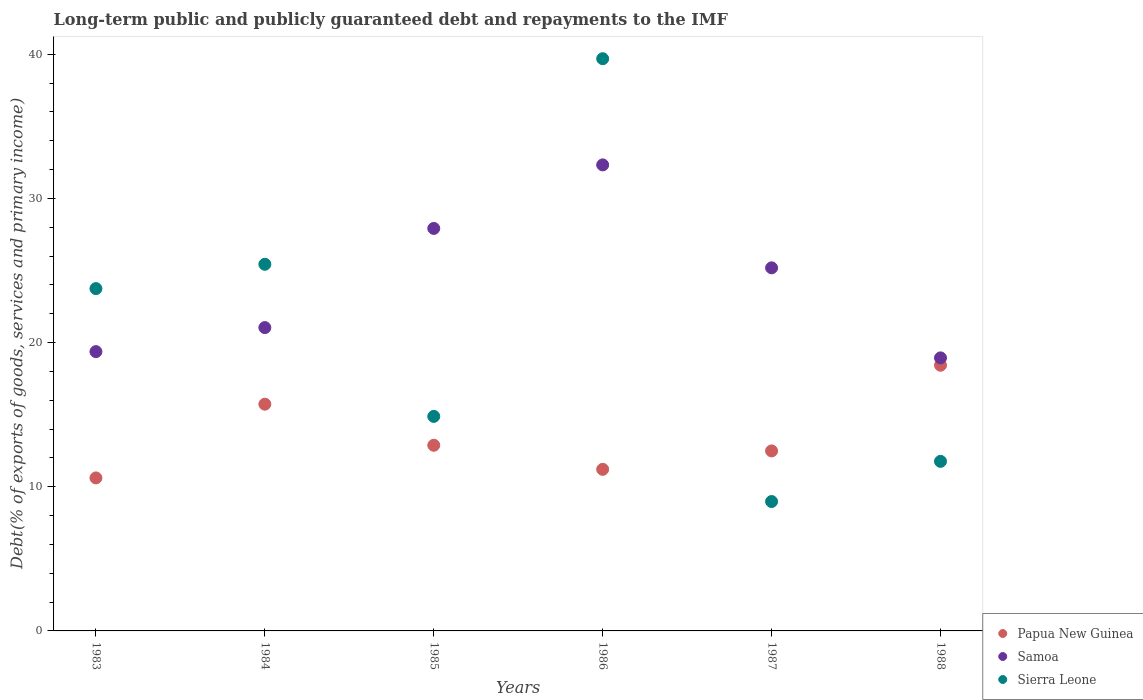Is the number of dotlines equal to the number of legend labels?
Your answer should be compact. Yes. What is the debt and repayments in Papua New Guinea in 1984?
Provide a succinct answer. 15.73. Across all years, what is the maximum debt and repayments in Papua New Guinea?
Provide a short and direct response. 18.43. Across all years, what is the minimum debt and repayments in Papua New Guinea?
Your answer should be compact. 10.61. What is the total debt and repayments in Samoa in the graph?
Provide a short and direct response. 144.76. What is the difference between the debt and repayments in Samoa in 1984 and that in 1988?
Your answer should be very brief. 2.1. What is the difference between the debt and repayments in Sierra Leone in 1983 and the debt and repayments in Samoa in 1986?
Your response must be concise. -8.58. What is the average debt and repayments in Papua New Guinea per year?
Keep it short and to the point. 13.55. In the year 1986, what is the difference between the debt and repayments in Sierra Leone and debt and repayments in Samoa?
Provide a short and direct response. 7.36. What is the ratio of the debt and repayments in Papua New Guinea in 1983 to that in 1986?
Offer a very short reply. 0.95. Is the debt and repayments in Sierra Leone in 1986 less than that in 1988?
Give a very brief answer. No. Is the difference between the debt and repayments in Sierra Leone in 1983 and 1987 greater than the difference between the debt and repayments in Samoa in 1983 and 1987?
Offer a very short reply. Yes. What is the difference between the highest and the second highest debt and repayments in Sierra Leone?
Make the answer very short. 14.26. What is the difference between the highest and the lowest debt and repayments in Papua New Guinea?
Keep it short and to the point. 7.81. Is it the case that in every year, the sum of the debt and repayments in Papua New Guinea and debt and repayments in Sierra Leone  is greater than the debt and repayments in Samoa?
Give a very brief answer. No. Does the debt and repayments in Sierra Leone monotonically increase over the years?
Your answer should be very brief. No. Is the debt and repayments in Samoa strictly greater than the debt and repayments in Sierra Leone over the years?
Make the answer very short. No. Where does the legend appear in the graph?
Your response must be concise. Bottom right. How many legend labels are there?
Give a very brief answer. 3. What is the title of the graph?
Your answer should be compact. Long-term public and publicly guaranteed debt and repayments to the IMF. What is the label or title of the Y-axis?
Offer a very short reply. Debt(% of exports of goods, services and primary income). What is the Debt(% of exports of goods, services and primary income) in Papua New Guinea in 1983?
Ensure brevity in your answer.  10.61. What is the Debt(% of exports of goods, services and primary income) in Samoa in 1983?
Offer a very short reply. 19.37. What is the Debt(% of exports of goods, services and primary income) of Sierra Leone in 1983?
Your answer should be compact. 23.74. What is the Debt(% of exports of goods, services and primary income) of Papua New Guinea in 1984?
Provide a succinct answer. 15.73. What is the Debt(% of exports of goods, services and primary income) of Samoa in 1984?
Provide a succinct answer. 21.04. What is the Debt(% of exports of goods, services and primary income) in Sierra Leone in 1984?
Your answer should be compact. 25.43. What is the Debt(% of exports of goods, services and primary income) of Papua New Guinea in 1985?
Make the answer very short. 12.88. What is the Debt(% of exports of goods, services and primary income) of Samoa in 1985?
Your response must be concise. 27.91. What is the Debt(% of exports of goods, services and primary income) in Sierra Leone in 1985?
Your answer should be very brief. 14.88. What is the Debt(% of exports of goods, services and primary income) of Papua New Guinea in 1986?
Offer a terse response. 11.21. What is the Debt(% of exports of goods, services and primary income) of Samoa in 1986?
Make the answer very short. 32.32. What is the Debt(% of exports of goods, services and primary income) in Sierra Leone in 1986?
Ensure brevity in your answer.  39.68. What is the Debt(% of exports of goods, services and primary income) of Papua New Guinea in 1987?
Give a very brief answer. 12.48. What is the Debt(% of exports of goods, services and primary income) in Samoa in 1987?
Offer a very short reply. 25.18. What is the Debt(% of exports of goods, services and primary income) in Sierra Leone in 1987?
Offer a very short reply. 8.97. What is the Debt(% of exports of goods, services and primary income) of Papua New Guinea in 1988?
Offer a terse response. 18.43. What is the Debt(% of exports of goods, services and primary income) in Samoa in 1988?
Offer a very short reply. 18.94. What is the Debt(% of exports of goods, services and primary income) in Sierra Leone in 1988?
Offer a terse response. 11.76. Across all years, what is the maximum Debt(% of exports of goods, services and primary income) of Papua New Guinea?
Your answer should be very brief. 18.43. Across all years, what is the maximum Debt(% of exports of goods, services and primary income) of Samoa?
Your response must be concise. 32.32. Across all years, what is the maximum Debt(% of exports of goods, services and primary income) in Sierra Leone?
Provide a succinct answer. 39.68. Across all years, what is the minimum Debt(% of exports of goods, services and primary income) in Papua New Guinea?
Make the answer very short. 10.61. Across all years, what is the minimum Debt(% of exports of goods, services and primary income) of Samoa?
Provide a short and direct response. 18.94. Across all years, what is the minimum Debt(% of exports of goods, services and primary income) in Sierra Leone?
Provide a succinct answer. 8.97. What is the total Debt(% of exports of goods, services and primary income) in Papua New Guinea in the graph?
Your answer should be compact. 81.33. What is the total Debt(% of exports of goods, services and primary income) in Samoa in the graph?
Your answer should be compact. 144.76. What is the total Debt(% of exports of goods, services and primary income) of Sierra Leone in the graph?
Provide a short and direct response. 124.47. What is the difference between the Debt(% of exports of goods, services and primary income) of Papua New Guinea in 1983 and that in 1984?
Offer a terse response. -5.11. What is the difference between the Debt(% of exports of goods, services and primary income) in Samoa in 1983 and that in 1984?
Keep it short and to the point. -1.67. What is the difference between the Debt(% of exports of goods, services and primary income) in Sierra Leone in 1983 and that in 1984?
Keep it short and to the point. -1.69. What is the difference between the Debt(% of exports of goods, services and primary income) in Papua New Guinea in 1983 and that in 1985?
Make the answer very short. -2.26. What is the difference between the Debt(% of exports of goods, services and primary income) in Samoa in 1983 and that in 1985?
Give a very brief answer. -8.54. What is the difference between the Debt(% of exports of goods, services and primary income) in Sierra Leone in 1983 and that in 1985?
Ensure brevity in your answer.  8.86. What is the difference between the Debt(% of exports of goods, services and primary income) of Papua New Guinea in 1983 and that in 1986?
Provide a short and direct response. -0.59. What is the difference between the Debt(% of exports of goods, services and primary income) of Samoa in 1983 and that in 1986?
Your answer should be compact. -12.95. What is the difference between the Debt(% of exports of goods, services and primary income) in Sierra Leone in 1983 and that in 1986?
Provide a short and direct response. -15.94. What is the difference between the Debt(% of exports of goods, services and primary income) in Papua New Guinea in 1983 and that in 1987?
Make the answer very short. -1.87. What is the difference between the Debt(% of exports of goods, services and primary income) in Samoa in 1983 and that in 1987?
Provide a succinct answer. -5.81. What is the difference between the Debt(% of exports of goods, services and primary income) of Sierra Leone in 1983 and that in 1987?
Offer a very short reply. 14.77. What is the difference between the Debt(% of exports of goods, services and primary income) of Papua New Guinea in 1983 and that in 1988?
Give a very brief answer. -7.81. What is the difference between the Debt(% of exports of goods, services and primary income) in Samoa in 1983 and that in 1988?
Your answer should be compact. 0.43. What is the difference between the Debt(% of exports of goods, services and primary income) of Sierra Leone in 1983 and that in 1988?
Ensure brevity in your answer.  11.98. What is the difference between the Debt(% of exports of goods, services and primary income) of Papua New Guinea in 1984 and that in 1985?
Provide a short and direct response. 2.85. What is the difference between the Debt(% of exports of goods, services and primary income) of Samoa in 1984 and that in 1985?
Your answer should be very brief. -6.88. What is the difference between the Debt(% of exports of goods, services and primary income) of Sierra Leone in 1984 and that in 1985?
Make the answer very short. 10.55. What is the difference between the Debt(% of exports of goods, services and primary income) in Papua New Guinea in 1984 and that in 1986?
Provide a succinct answer. 4.52. What is the difference between the Debt(% of exports of goods, services and primary income) of Samoa in 1984 and that in 1986?
Offer a very short reply. -11.28. What is the difference between the Debt(% of exports of goods, services and primary income) in Sierra Leone in 1984 and that in 1986?
Ensure brevity in your answer.  -14.26. What is the difference between the Debt(% of exports of goods, services and primary income) in Papua New Guinea in 1984 and that in 1987?
Keep it short and to the point. 3.24. What is the difference between the Debt(% of exports of goods, services and primary income) of Samoa in 1984 and that in 1987?
Keep it short and to the point. -4.14. What is the difference between the Debt(% of exports of goods, services and primary income) of Sierra Leone in 1984 and that in 1987?
Provide a succinct answer. 16.45. What is the difference between the Debt(% of exports of goods, services and primary income) of Papua New Guinea in 1984 and that in 1988?
Your answer should be very brief. -2.7. What is the difference between the Debt(% of exports of goods, services and primary income) of Samoa in 1984 and that in 1988?
Keep it short and to the point. 2.1. What is the difference between the Debt(% of exports of goods, services and primary income) of Sierra Leone in 1984 and that in 1988?
Give a very brief answer. 13.67. What is the difference between the Debt(% of exports of goods, services and primary income) of Papua New Guinea in 1985 and that in 1986?
Make the answer very short. 1.67. What is the difference between the Debt(% of exports of goods, services and primary income) of Samoa in 1985 and that in 1986?
Your answer should be compact. -4.41. What is the difference between the Debt(% of exports of goods, services and primary income) of Sierra Leone in 1985 and that in 1986?
Your answer should be very brief. -24.81. What is the difference between the Debt(% of exports of goods, services and primary income) of Papua New Guinea in 1985 and that in 1987?
Keep it short and to the point. 0.39. What is the difference between the Debt(% of exports of goods, services and primary income) of Samoa in 1985 and that in 1987?
Your response must be concise. 2.73. What is the difference between the Debt(% of exports of goods, services and primary income) in Sierra Leone in 1985 and that in 1987?
Keep it short and to the point. 5.9. What is the difference between the Debt(% of exports of goods, services and primary income) in Papua New Guinea in 1985 and that in 1988?
Offer a very short reply. -5.55. What is the difference between the Debt(% of exports of goods, services and primary income) in Samoa in 1985 and that in 1988?
Provide a succinct answer. 8.98. What is the difference between the Debt(% of exports of goods, services and primary income) of Sierra Leone in 1985 and that in 1988?
Ensure brevity in your answer.  3.12. What is the difference between the Debt(% of exports of goods, services and primary income) in Papua New Guinea in 1986 and that in 1987?
Offer a terse response. -1.28. What is the difference between the Debt(% of exports of goods, services and primary income) of Samoa in 1986 and that in 1987?
Make the answer very short. 7.14. What is the difference between the Debt(% of exports of goods, services and primary income) in Sierra Leone in 1986 and that in 1987?
Offer a very short reply. 30.71. What is the difference between the Debt(% of exports of goods, services and primary income) of Papua New Guinea in 1986 and that in 1988?
Ensure brevity in your answer.  -7.22. What is the difference between the Debt(% of exports of goods, services and primary income) in Samoa in 1986 and that in 1988?
Make the answer very short. 13.38. What is the difference between the Debt(% of exports of goods, services and primary income) in Sierra Leone in 1986 and that in 1988?
Make the answer very short. 27.92. What is the difference between the Debt(% of exports of goods, services and primary income) of Papua New Guinea in 1987 and that in 1988?
Your response must be concise. -5.94. What is the difference between the Debt(% of exports of goods, services and primary income) in Samoa in 1987 and that in 1988?
Give a very brief answer. 6.25. What is the difference between the Debt(% of exports of goods, services and primary income) in Sierra Leone in 1987 and that in 1988?
Make the answer very short. -2.79. What is the difference between the Debt(% of exports of goods, services and primary income) of Papua New Guinea in 1983 and the Debt(% of exports of goods, services and primary income) of Samoa in 1984?
Your answer should be compact. -10.43. What is the difference between the Debt(% of exports of goods, services and primary income) of Papua New Guinea in 1983 and the Debt(% of exports of goods, services and primary income) of Sierra Leone in 1984?
Ensure brevity in your answer.  -14.82. What is the difference between the Debt(% of exports of goods, services and primary income) of Samoa in 1983 and the Debt(% of exports of goods, services and primary income) of Sierra Leone in 1984?
Keep it short and to the point. -6.06. What is the difference between the Debt(% of exports of goods, services and primary income) of Papua New Guinea in 1983 and the Debt(% of exports of goods, services and primary income) of Samoa in 1985?
Offer a very short reply. -17.3. What is the difference between the Debt(% of exports of goods, services and primary income) in Papua New Guinea in 1983 and the Debt(% of exports of goods, services and primary income) in Sierra Leone in 1985?
Make the answer very short. -4.27. What is the difference between the Debt(% of exports of goods, services and primary income) of Samoa in 1983 and the Debt(% of exports of goods, services and primary income) of Sierra Leone in 1985?
Your answer should be compact. 4.49. What is the difference between the Debt(% of exports of goods, services and primary income) in Papua New Guinea in 1983 and the Debt(% of exports of goods, services and primary income) in Samoa in 1986?
Keep it short and to the point. -21.71. What is the difference between the Debt(% of exports of goods, services and primary income) in Papua New Guinea in 1983 and the Debt(% of exports of goods, services and primary income) in Sierra Leone in 1986?
Give a very brief answer. -29.07. What is the difference between the Debt(% of exports of goods, services and primary income) of Samoa in 1983 and the Debt(% of exports of goods, services and primary income) of Sierra Leone in 1986?
Your answer should be very brief. -20.31. What is the difference between the Debt(% of exports of goods, services and primary income) of Papua New Guinea in 1983 and the Debt(% of exports of goods, services and primary income) of Samoa in 1987?
Offer a terse response. -14.57. What is the difference between the Debt(% of exports of goods, services and primary income) in Papua New Guinea in 1983 and the Debt(% of exports of goods, services and primary income) in Sierra Leone in 1987?
Provide a short and direct response. 1.64. What is the difference between the Debt(% of exports of goods, services and primary income) of Samoa in 1983 and the Debt(% of exports of goods, services and primary income) of Sierra Leone in 1987?
Keep it short and to the point. 10.4. What is the difference between the Debt(% of exports of goods, services and primary income) in Papua New Guinea in 1983 and the Debt(% of exports of goods, services and primary income) in Samoa in 1988?
Provide a short and direct response. -8.32. What is the difference between the Debt(% of exports of goods, services and primary income) of Papua New Guinea in 1983 and the Debt(% of exports of goods, services and primary income) of Sierra Leone in 1988?
Make the answer very short. -1.15. What is the difference between the Debt(% of exports of goods, services and primary income) of Samoa in 1983 and the Debt(% of exports of goods, services and primary income) of Sierra Leone in 1988?
Keep it short and to the point. 7.61. What is the difference between the Debt(% of exports of goods, services and primary income) in Papua New Guinea in 1984 and the Debt(% of exports of goods, services and primary income) in Samoa in 1985?
Ensure brevity in your answer.  -12.19. What is the difference between the Debt(% of exports of goods, services and primary income) in Papua New Guinea in 1984 and the Debt(% of exports of goods, services and primary income) in Sierra Leone in 1985?
Provide a short and direct response. 0.85. What is the difference between the Debt(% of exports of goods, services and primary income) of Samoa in 1984 and the Debt(% of exports of goods, services and primary income) of Sierra Leone in 1985?
Make the answer very short. 6.16. What is the difference between the Debt(% of exports of goods, services and primary income) in Papua New Guinea in 1984 and the Debt(% of exports of goods, services and primary income) in Samoa in 1986?
Keep it short and to the point. -16.6. What is the difference between the Debt(% of exports of goods, services and primary income) in Papua New Guinea in 1984 and the Debt(% of exports of goods, services and primary income) in Sierra Leone in 1986?
Offer a terse response. -23.96. What is the difference between the Debt(% of exports of goods, services and primary income) in Samoa in 1984 and the Debt(% of exports of goods, services and primary income) in Sierra Leone in 1986?
Offer a very short reply. -18.65. What is the difference between the Debt(% of exports of goods, services and primary income) of Papua New Guinea in 1984 and the Debt(% of exports of goods, services and primary income) of Samoa in 1987?
Make the answer very short. -9.46. What is the difference between the Debt(% of exports of goods, services and primary income) of Papua New Guinea in 1984 and the Debt(% of exports of goods, services and primary income) of Sierra Leone in 1987?
Provide a short and direct response. 6.75. What is the difference between the Debt(% of exports of goods, services and primary income) of Samoa in 1984 and the Debt(% of exports of goods, services and primary income) of Sierra Leone in 1987?
Make the answer very short. 12.06. What is the difference between the Debt(% of exports of goods, services and primary income) of Papua New Guinea in 1984 and the Debt(% of exports of goods, services and primary income) of Samoa in 1988?
Provide a succinct answer. -3.21. What is the difference between the Debt(% of exports of goods, services and primary income) of Papua New Guinea in 1984 and the Debt(% of exports of goods, services and primary income) of Sierra Leone in 1988?
Offer a very short reply. 3.96. What is the difference between the Debt(% of exports of goods, services and primary income) of Samoa in 1984 and the Debt(% of exports of goods, services and primary income) of Sierra Leone in 1988?
Offer a terse response. 9.28. What is the difference between the Debt(% of exports of goods, services and primary income) of Papua New Guinea in 1985 and the Debt(% of exports of goods, services and primary income) of Samoa in 1986?
Your answer should be compact. -19.45. What is the difference between the Debt(% of exports of goods, services and primary income) in Papua New Guinea in 1985 and the Debt(% of exports of goods, services and primary income) in Sierra Leone in 1986?
Give a very brief answer. -26.81. What is the difference between the Debt(% of exports of goods, services and primary income) in Samoa in 1985 and the Debt(% of exports of goods, services and primary income) in Sierra Leone in 1986?
Your answer should be compact. -11.77. What is the difference between the Debt(% of exports of goods, services and primary income) in Papua New Guinea in 1985 and the Debt(% of exports of goods, services and primary income) in Samoa in 1987?
Make the answer very short. -12.31. What is the difference between the Debt(% of exports of goods, services and primary income) of Papua New Guinea in 1985 and the Debt(% of exports of goods, services and primary income) of Sierra Leone in 1987?
Your response must be concise. 3.9. What is the difference between the Debt(% of exports of goods, services and primary income) in Samoa in 1985 and the Debt(% of exports of goods, services and primary income) in Sierra Leone in 1987?
Your answer should be compact. 18.94. What is the difference between the Debt(% of exports of goods, services and primary income) of Papua New Guinea in 1985 and the Debt(% of exports of goods, services and primary income) of Samoa in 1988?
Your answer should be compact. -6.06. What is the difference between the Debt(% of exports of goods, services and primary income) of Papua New Guinea in 1985 and the Debt(% of exports of goods, services and primary income) of Sierra Leone in 1988?
Offer a very short reply. 1.11. What is the difference between the Debt(% of exports of goods, services and primary income) in Samoa in 1985 and the Debt(% of exports of goods, services and primary income) in Sierra Leone in 1988?
Your response must be concise. 16.15. What is the difference between the Debt(% of exports of goods, services and primary income) of Papua New Guinea in 1986 and the Debt(% of exports of goods, services and primary income) of Samoa in 1987?
Offer a terse response. -13.98. What is the difference between the Debt(% of exports of goods, services and primary income) of Papua New Guinea in 1986 and the Debt(% of exports of goods, services and primary income) of Sierra Leone in 1987?
Your answer should be very brief. 2.23. What is the difference between the Debt(% of exports of goods, services and primary income) in Samoa in 1986 and the Debt(% of exports of goods, services and primary income) in Sierra Leone in 1987?
Your answer should be compact. 23.35. What is the difference between the Debt(% of exports of goods, services and primary income) of Papua New Guinea in 1986 and the Debt(% of exports of goods, services and primary income) of Samoa in 1988?
Ensure brevity in your answer.  -7.73. What is the difference between the Debt(% of exports of goods, services and primary income) of Papua New Guinea in 1986 and the Debt(% of exports of goods, services and primary income) of Sierra Leone in 1988?
Your response must be concise. -0.55. What is the difference between the Debt(% of exports of goods, services and primary income) in Samoa in 1986 and the Debt(% of exports of goods, services and primary income) in Sierra Leone in 1988?
Offer a terse response. 20.56. What is the difference between the Debt(% of exports of goods, services and primary income) in Papua New Guinea in 1987 and the Debt(% of exports of goods, services and primary income) in Samoa in 1988?
Give a very brief answer. -6.45. What is the difference between the Debt(% of exports of goods, services and primary income) in Papua New Guinea in 1987 and the Debt(% of exports of goods, services and primary income) in Sierra Leone in 1988?
Your answer should be very brief. 0.72. What is the difference between the Debt(% of exports of goods, services and primary income) of Samoa in 1987 and the Debt(% of exports of goods, services and primary income) of Sierra Leone in 1988?
Provide a succinct answer. 13.42. What is the average Debt(% of exports of goods, services and primary income) in Papua New Guinea per year?
Your response must be concise. 13.55. What is the average Debt(% of exports of goods, services and primary income) in Samoa per year?
Provide a succinct answer. 24.13. What is the average Debt(% of exports of goods, services and primary income) of Sierra Leone per year?
Offer a very short reply. 20.74. In the year 1983, what is the difference between the Debt(% of exports of goods, services and primary income) of Papua New Guinea and Debt(% of exports of goods, services and primary income) of Samoa?
Provide a succinct answer. -8.76. In the year 1983, what is the difference between the Debt(% of exports of goods, services and primary income) of Papua New Guinea and Debt(% of exports of goods, services and primary income) of Sierra Leone?
Your answer should be compact. -13.13. In the year 1983, what is the difference between the Debt(% of exports of goods, services and primary income) in Samoa and Debt(% of exports of goods, services and primary income) in Sierra Leone?
Your answer should be compact. -4.37. In the year 1984, what is the difference between the Debt(% of exports of goods, services and primary income) in Papua New Guinea and Debt(% of exports of goods, services and primary income) in Samoa?
Offer a very short reply. -5.31. In the year 1984, what is the difference between the Debt(% of exports of goods, services and primary income) in Papua New Guinea and Debt(% of exports of goods, services and primary income) in Sierra Leone?
Your answer should be very brief. -9.7. In the year 1984, what is the difference between the Debt(% of exports of goods, services and primary income) of Samoa and Debt(% of exports of goods, services and primary income) of Sierra Leone?
Your response must be concise. -4.39. In the year 1985, what is the difference between the Debt(% of exports of goods, services and primary income) in Papua New Guinea and Debt(% of exports of goods, services and primary income) in Samoa?
Keep it short and to the point. -15.04. In the year 1985, what is the difference between the Debt(% of exports of goods, services and primary income) of Papua New Guinea and Debt(% of exports of goods, services and primary income) of Sierra Leone?
Ensure brevity in your answer.  -2. In the year 1985, what is the difference between the Debt(% of exports of goods, services and primary income) in Samoa and Debt(% of exports of goods, services and primary income) in Sierra Leone?
Ensure brevity in your answer.  13.04. In the year 1986, what is the difference between the Debt(% of exports of goods, services and primary income) of Papua New Guinea and Debt(% of exports of goods, services and primary income) of Samoa?
Make the answer very short. -21.12. In the year 1986, what is the difference between the Debt(% of exports of goods, services and primary income) of Papua New Guinea and Debt(% of exports of goods, services and primary income) of Sierra Leone?
Keep it short and to the point. -28.48. In the year 1986, what is the difference between the Debt(% of exports of goods, services and primary income) of Samoa and Debt(% of exports of goods, services and primary income) of Sierra Leone?
Provide a short and direct response. -7.36. In the year 1987, what is the difference between the Debt(% of exports of goods, services and primary income) in Papua New Guinea and Debt(% of exports of goods, services and primary income) in Samoa?
Offer a very short reply. -12.7. In the year 1987, what is the difference between the Debt(% of exports of goods, services and primary income) in Papua New Guinea and Debt(% of exports of goods, services and primary income) in Sierra Leone?
Your answer should be compact. 3.51. In the year 1987, what is the difference between the Debt(% of exports of goods, services and primary income) of Samoa and Debt(% of exports of goods, services and primary income) of Sierra Leone?
Make the answer very short. 16.21. In the year 1988, what is the difference between the Debt(% of exports of goods, services and primary income) of Papua New Guinea and Debt(% of exports of goods, services and primary income) of Samoa?
Your answer should be compact. -0.51. In the year 1988, what is the difference between the Debt(% of exports of goods, services and primary income) in Papua New Guinea and Debt(% of exports of goods, services and primary income) in Sierra Leone?
Your response must be concise. 6.67. In the year 1988, what is the difference between the Debt(% of exports of goods, services and primary income) in Samoa and Debt(% of exports of goods, services and primary income) in Sierra Leone?
Offer a very short reply. 7.18. What is the ratio of the Debt(% of exports of goods, services and primary income) in Papua New Guinea in 1983 to that in 1984?
Ensure brevity in your answer.  0.67. What is the ratio of the Debt(% of exports of goods, services and primary income) of Samoa in 1983 to that in 1984?
Your answer should be very brief. 0.92. What is the ratio of the Debt(% of exports of goods, services and primary income) in Sierra Leone in 1983 to that in 1984?
Your answer should be compact. 0.93. What is the ratio of the Debt(% of exports of goods, services and primary income) in Papua New Guinea in 1983 to that in 1985?
Your response must be concise. 0.82. What is the ratio of the Debt(% of exports of goods, services and primary income) in Samoa in 1983 to that in 1985?
Provide a succinct answer. 0.69. What is the ratio of the Debt(% of exports of goods, services and primary income) of Sierra Leone in 1983 to that in 1985?
Make the answer very short. 1.6. What is the ratio of the Debt(% of exports of goods, services and primary income) in Papua New Guinea in 1983 to that in 1986?
Make the answer very short. 0.95. What is the ratio of the Debt(% of exports of goods, services and primary income) of Samoa in 1983 to that in 1986?
Offer a very short reply. 0.6. What is the ratio of the Debt(% of exports of goods, services and primary income) of Sierra Leone in 1983 to that in 1986?
Your response must be concise. 0.6. What is the ratio of the Debt(% of exports of goods, services and primary income) in Papua New Guinea in 1983 to that in 1987?
Your answer should be very brief. 0.85. What is the ratio of the Debt(% of exports of goods, services and primary income) in Samoa in 1983 to that in 1987?
Provide a succinct answer. 0.77. What is the ratio of the Debt(% of exports of goods, services and primary income) of Sierra Leone in 1983 to that in 1987?
Your response must be concise. 2.65. What is the ratio of the Debt(% of exports of goods, services and primary income) of Papua New Guinea in 1983 to that in 1988?
Offer a terse response. 0.58. What is the ratio of the Debt(% of exports of goods, services and primary income) in Samoa in 1983 to that in 1988?
Your answer should be compact. 1.02. What is the ratio of the Debt(% of exports of goods, services and primary income) in Sierra Leone in 1983 to that in 1988?
Give a very brief answer. 2.02. What is the ratio of the Debt(% of exports of goods, services and primary income) of Papua New Guinea in 1984 to that in 1985?
Provide a short and direct response. 1.22. What is the ratio of the Debt(% of exports of goods, services and primary income) of Samoa in 1984 to that in 1985?
Provide a succinct answer. 0.75. What is the ratio of the Debt(% of exports of goods, services and primary income) in Sierra Leone in 1984 to that in 1985?
Provide a succinct answer. 1.71. What is the ratio of the Debt(% of exports of goods, services and primary income) of Papua New Guinea in 1984 to that in 1986?
Provide a short and direct response. 1.4. What is the ratio of the Debt(% of exports of goods, services and primary income) of Samoa in 1984 to that in 1986?
Your answer should be compact. 0.65. What is the ratio of the Debt(% of exports of goods, services and primary income) of Sierra Leone in 1984 to that in 1986?
Make the answer very short. 0.64. What is the ratio of the Debt(% of exports of goods, services and primary income) of Papua New Guinea in 1984 to that in 1987?
Your answer should be very brief. 1.26. What is the ratio of the Debt(% of exports of goods, services and primary income) in Samoa in 1984 to that in 1987?
Give a very brief answer. 0.84. What is the ratio of the Debt(% of exports of goods, services and primary income) in Sierra Leone in 1984 to that in 1987?
Your answer should be very brief. 2.83. What is the ratio of the Debt(% of exports of goods, services and primary income) of Papua New Guinea in 1984 to that in 1988?
Your answer should be compact. 0.85. What is the ratio of the Debt(% of exports of goods, services and primary income) of Samoa in 1984 to that in 1988?
Give a very brief answer. 1.11. What is the ratio of the Debt(% of exports of goods, services and primary income) of Sierra Leone in 1984 to that in 1988?
Give a very brief answer. 2.16. What is the ratio of the Debt(% of exports of goods, services and primary income) of Papua New Guinea in 1985 to that in 1986?
Ensure brevity in your answer.  1.15. What is the ratio of the Debt(% of exports of goods, services and primary income) of Samoa in 1985 to that in 1986?
Provide a short and direct response. 0.86. What is the ratio of the Debt(% of exports of goods, services and primary income) of Sierra Leone in 1985 to that in 1986?
Your answer should be very brief. 0.37. What is the ratio of the Debt(% of exports of goods, services and primary income) of Papua New Guinea in 1985 to that in 1987?
Provide a short and direct response. 1.03. What is the ratio of the Debt(% of exports of goods, services and primary income) in Samoa in 1985 to that in 1987?
Your response must be concise. 1.11. What is the ratio of the Debt(% of exports of goods, services and primary income) of Sierra Leone in 1985 to that in 1987?
Provide a short and direct response. 1.66. What is the ratio of the Debt(% of exports of goods, services and primary income) in Papua New Guinea in 1985 to that in 1988?
Provide a succinct answer. 0.7. What is the ratio of the Debt(% of exports of goods, services and primary income) of Samoa in 1985 to that in 1988?
Make the answer very short. 1.47. What is the ratio of the Debt(% of exports of goods, services and primary income) in Sierra Leone in 1985 to that in 1988?
Make the answer very short. 1.27. What is the ratio of the Debt(% of exports of goods, services and primary income) in Papua New Guinea in 1986 to that in 1987?
Your response must be concise. 0.9. What is the ratio of the Debt(% of exports of goods, services and primary income) of Samoa in 1986 to that in 1987?
Give a very brief answer. 1.28. What is the ratio of the Debt(% of exports of goods, services and primary income) of Sierra Leone in 1986 to that in 1987?
Ensure brevity in your answer.  4.42. What is the ratio of the Debt(% of exports of goods, services and primary income) of Papua New Guinea in 1986 to that in 1988?
Your response must be concise. 0.61. What is the ratio of the Debt(% of exports of goods, services and primary income) in Samoa in 1986 to that in 1988?
Your response must be concise. 1.71. What is the ratio of the Debt(% of exports of goods, services and primary income) in Sierra Leone in 1986 to that in 1988?
Your answer should be compact. 3.37. What is the ratio of the Debt(% of exports of goods, services and primary income) of Papua New Guinea in 1987 to that in 1988?
Offer a terse response. 0.68. What is the ratio of the Debt(% of exports of goods, services and primary income) in Samoa in 1987 to that in 1988?
Your answer should be very brief. 1.33. What is the ratio of the Debt(% of exports of goods, services and primary income) of Sierra Leone in 1987 to that in 1988?
Ensure brevity in your answer.  0.76. What is the difference between the highest and the second highest Debt(% of exports of goods, services and primary income) of Papua New Guinea?
Provide a succinct answer. 2.7. What is the difference between the highest and the second highest Debt(% of exports of goods, services and primary income) in Samoa?
Offer a terse response. 4.41. What is the difference between the highest and the second highest Debt(% of exports of goods, services and primary income) of Sierra Leone?
Ensure brevity in your answer.  14.26. What is the difference between the highest and the lowest Debt(% of exports of goods, services and primary income) in Papua New Guinea?
Provide a succinct answer. 7.81. What is the difference between the highest and the lowest Debt(% of exports of goods, services and primary income) of Samoa?
Provide a succinct answer. 13.38. What is the difference between the highest and the lowest Debt(% of exports of goods, services and primary income) in Sierra Leone?
Your response must be concise. 30.71. 